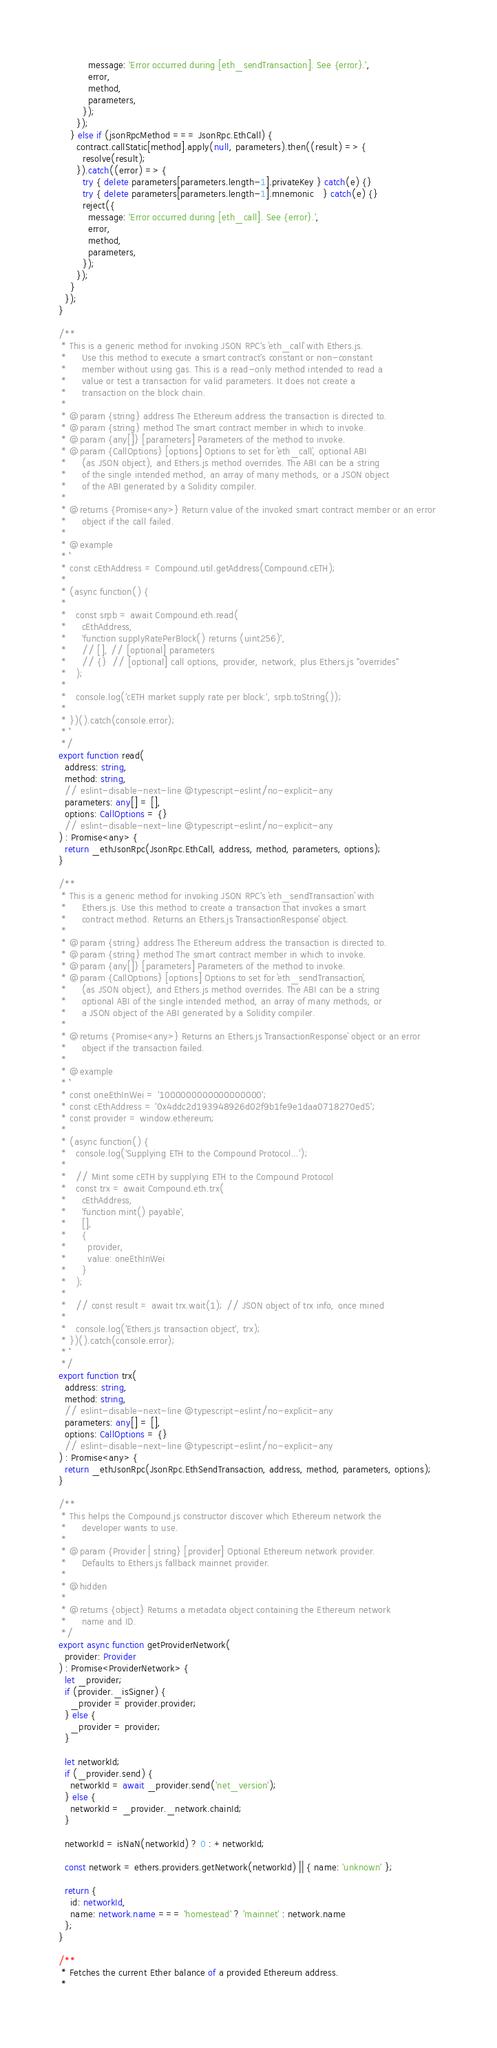Convert code to text. <code><loc_0><loc_0><loc_500><loc_500><_TypeScript_>          message: 'Error occurred during [eth_sendTransaction]. See {error}.',
          error,
          method,
          parameters,
        });
      });
    } else if (jsonRpcMethod === JsonRpc.EthCall) {
      contract.callStatic[method].apply(null, parameters).then((result) => {
        resolve(result);
      }).catch((error) => {
        try { delete parameters[parameters.length-1].privateKey } catch(e) {}
        try { delete parameters[parameters.length-1].mnemonic   } catch(e) {}
        reject({
          message: 'Error occurred during [eth_call]. See {error}.',
          error,
          method,
          parameters,
        });
      });
    }
  });
}

/**
 * This is a generic method for invoking JSON RPC's `eth_call` with Ethers.js. 
 *     Use this method to execute a smart contract's constant or non-constant 
 *     member without using gas. This is a read-only method intended to read a 
 *     value or test a transaction for valid parameters. It does not create a 
 *     transaction on the block chain.
 *
 * @param {string} address The Ethereum address the transaction is directed to.
 * @param {string} method The smart contract member in which to invoke.
 * @param {any[]} [parameters] Parameters of the method to invoke.
 * @param {CallOptions} [options] Options to set for `eth_call`, optional ABI
 *     (as JSON object), and Ethers.js method overrides. The ABI can be a string
 *     of the single intended method, an array of many methods, or a JSON object
 *     of the ABI generated by a Solidity compiler.
 *
 * @returns {Promise<any>} Return value of the invoked smart contract member or an error 
 *     object if the call failed.
 *
 * @example
 * ```
 * const cEthAddress = Compound.util.getAddress(Compound.cETH);
 * 
 * (async function() {
 * 
 *   const srpb = await Compound.eth.read(
 *     cEthAddress,
 *     'function supplyRatePerBlock() returns (uint256)',
 *     // [], // [optional] parameters
 *     // {}  // [optional] call options, provider, network, plus Ethers.js "overrides"
 *   );
 * 
 *   console.log('cETH market supply rate per block:', srpb.toString());
 * 
 * })().catch(console.error);
 * ```
 */
export function read(
  address: string,
  method: string,
  // eslint-disable-next-line @typescript-eslint/no-explicit-any
  parameters: any[] = [],
  options: CallOptions = {}
  // eslint-disable-next-line @typescript-eslint/no-explicit-any
) : Promise<any> {
  return _ethJsonRpc(JsonRpc.EthCall, address, method, parameters, options);
}

/**
 * This is a generic method for invoking JSON RPC's `eth_sendTransaction` with 
 *     Ethers.js. Use this method to create a transaction that invokes a smart 
 *     contract method. Returns an Ethers.js `TransactionResponse` object.
 *
 * @param {string} address The Ethereum address the transaction is directed to.
 * @param {string} method The smart contract member in which to invoke.
 * @param {any[]} [parameters] Parameters of the method to invoke.
 * @param {CallOptions} [options] Options to set for `eth_sendTransaction`, 
 *     (as JSON object), and Ethers.js method overrides. The ABI can be a string
 *     optional ABI of the single intended method, an array of many methods, or 
 *     a JSON object of the ABI generated by a Solidity compiler.
 *
 * @returns {Promise<any>} Returns an Ethers.js `TransactionResponse` object or an error 
 *     object if the transaction failed.
 *
 * @example
 * ```
 * const oneEthInWei = '1000000000000000000';
 * const cEthAddress = '0x4ddc2d193948926d02f9b1fe9e1daa0718270ed5';
 * const provider = window.ethereum;
 * 
 * (async function() {
 *   console.log('Supplying ETH to the Compound Protocol...');
 * 
 *   // Mint some cETH by supplying ETH to the Compound Protocol
 *   const trx = await Compound.eth.trx(
 *     cEthAddress,
 *     'function mint() payable',
 *     [],
 *     {
 *       provider,
 *       value: oneEthInWei
 *     }
 *   );
 * 
 *   // const result = await trx.wait(1); // JSON object of trx info, once mined
 * 
 *   console.log('Ethers.js transaction object', trx);
 * })().catch(console.error);
 * ```
 */
export function trx(
  address: string,
  method: string,
  // eslint-disable-next-line @typescript-eslint/no-explicit-any
  parameters: any[] = [],
  options: CallOptions = {}
  // eslint-disable-next-line @typescript-eslint/no-explicit-any
) : Promise<any> {
  return _ethJsonRpc(JsonRpc.EthSendTransaction, address, method, parameters, options);
}

/**
 * This helps the Compound.js constructor discover which Ethereum network the
 *     developer wants to use.
 *
 * @param {Provider | string} [provider] Optional Ethereum network provider.
 *     Defaults to Ethers.js fallback mainnet provider.
 *
 * @hidden
 *
 * @returns {object} Returns a metadata object containing the Ethereum network
 *     name and ID.
 */
export async function getProviderNetwork(
  provider: Provider
) : Promise<ProviderNetwork> {
  let _provider;
  if (provider._isSigner) {
    _provider = provider.provider;
  } else {
    _provider = provider;
  }

  let networkId;
  if (_provider.send) {
    networkId = await _provider.send('net_version');
  } else {
    networkId = _provider._network.chainId;
  }

  networkId = isNaN(networkId) ? 0 : +networkId;

  const network = ethers.providers.getNetwork(networkId) || { name: 'unknown' };

  return {
    id: networkId,
    name: network.name === 'homestead' ? 'mainnet' : network.name
  };
}

/**
 * Fetches the current Ether balance of a provided Ethereum address.
 *</code> 